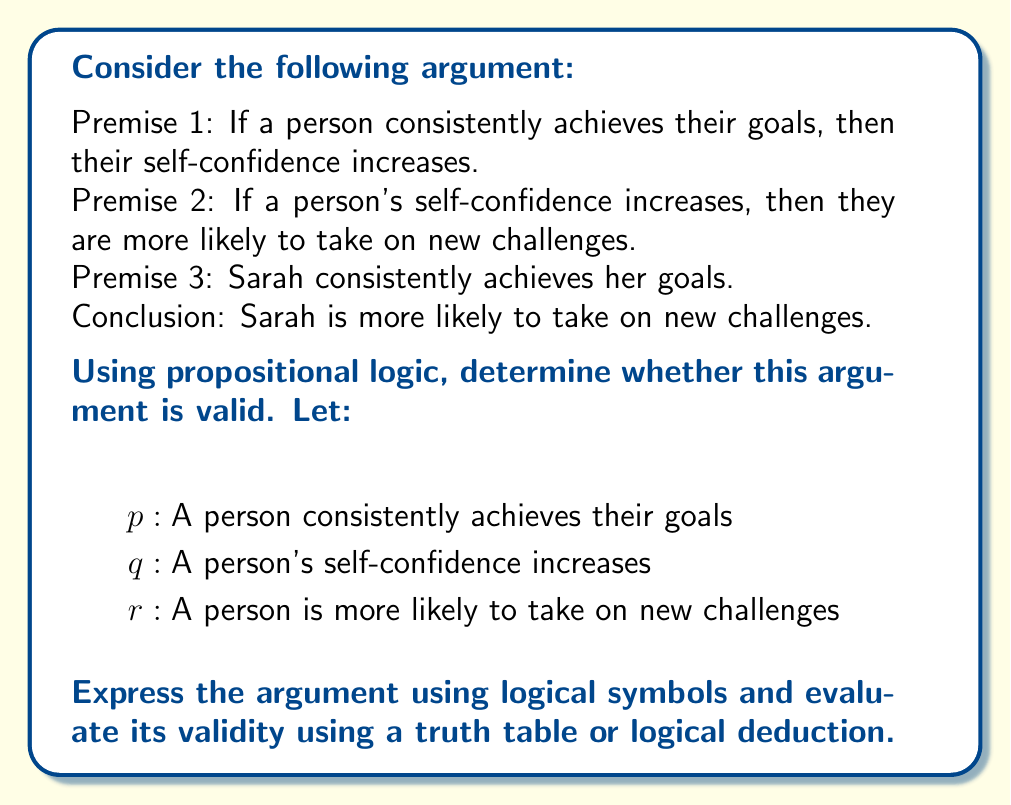Solve this math problem. To determine the validity of this argument, we'll follow these steps:

1. Express the argument using logical symbols:
   Premise 1: $p \rightarrow q$
   Premise 2: $q \rightarrow r$
   Premise 3: $p$
   Conclusion: $r$

2. The argument form is:
   $$(p \rightarrow q) \land (q \rightarrow r) \land p \therefore r$$

3. This argument form is known as the chain rule or hypothetical syllogism combined with modus ponens. We can prove its validity using logical deduction:

   a) From premise 1 and premise 3, we can apply modus ponens:
      $p \rightarrow q$
      $p$
      $\therefore q$

   b) Now we have $q$, and from premise 2, we can apply modus ponens again:
      $q \rightarrow r$
      $q$
      $\therefore r$

4. Alternatively, we can use a truth table to show that whenever all premises are true, the conclusion must also be true:

   $$\begin{array}{cccccc}
   p & q & r & p \rightarrow q & q \rightarrow r & ((p \rightarrow q) \land (q \rightarrow r) \land p) \rightarrow r \\
   \hline
   T & T & T & T & T & T \\
   T & T & F & T & F & T \\
   T & F & T & F & T & T \\
   T & F & F & F & T & T \\
   F & T & T & T & T & T \\
   F & T & F & T & F & T \\
   F & F & T & T & T & T \\
   F & F & F & T & T & T \\
   \end{array}$$

   The last column shows that the argument is always true, regardless of the truth values of $p$, $q$, and $r$, which proves its validity.

5. In the context of the question, this logical analysis shows that if we accept the premises as true, then the conclusion logically follows. This means that if Sarah consistently achieves her goals, and we accept the relationships between goal achievement, self-confidence, and taking on new challenges as stated in the premises, then we can logically conclude that Sarah is more likely to take on new challenges.
Answer: The argument is valid. The logical form of the argument is an instance of the chain rule (hypothetical syllogism) combined with modus ponens, which is a valid argument form in propositional logic. This can be proven through logical deduction or by constructing a truth table, both of which demonstrate that if all premises are true, the conclusion must also be true. 